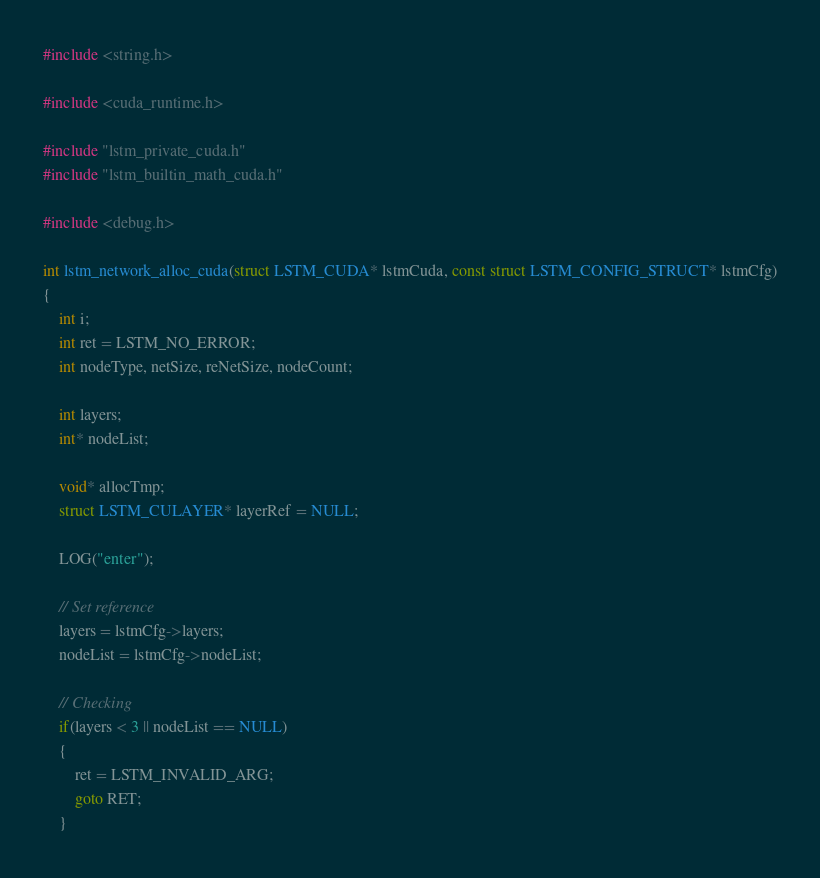<code> <loc_0><loc_0><loc_500><loc_500><_Cuda_>#include <string.h>

#include <cuda_runtime.h>

#include "lstm_private_cuda.h"
#include "lstm_builtin_math_cuda.h"

#include <debug.h>

int lstm_network_alloc_cuda(struct LSTM_CUDA* lstmCuda, const struct LSTM_CONFIG_STRUCT* lstmCfg)
{
	int i;
	int ret = LSTM_NO_ERROR;
	int nodeType, netSize, reNetSize, nodeCount;

	int layers;
	int* nodeList;

	void* allocTmp;
	struct LSTM_CULAYER* layerRef = NULL;

	LOG("enter");

	// Set reference
	layers = lstmCfg->layers;
	nodeList = lstmCfg->nodeList;

	// Checking
	if(layers < 3 || nodeList == NULL)
	{
		ret = LSTM_INVALID_ARG;
		goto RET;
	}
</code> 